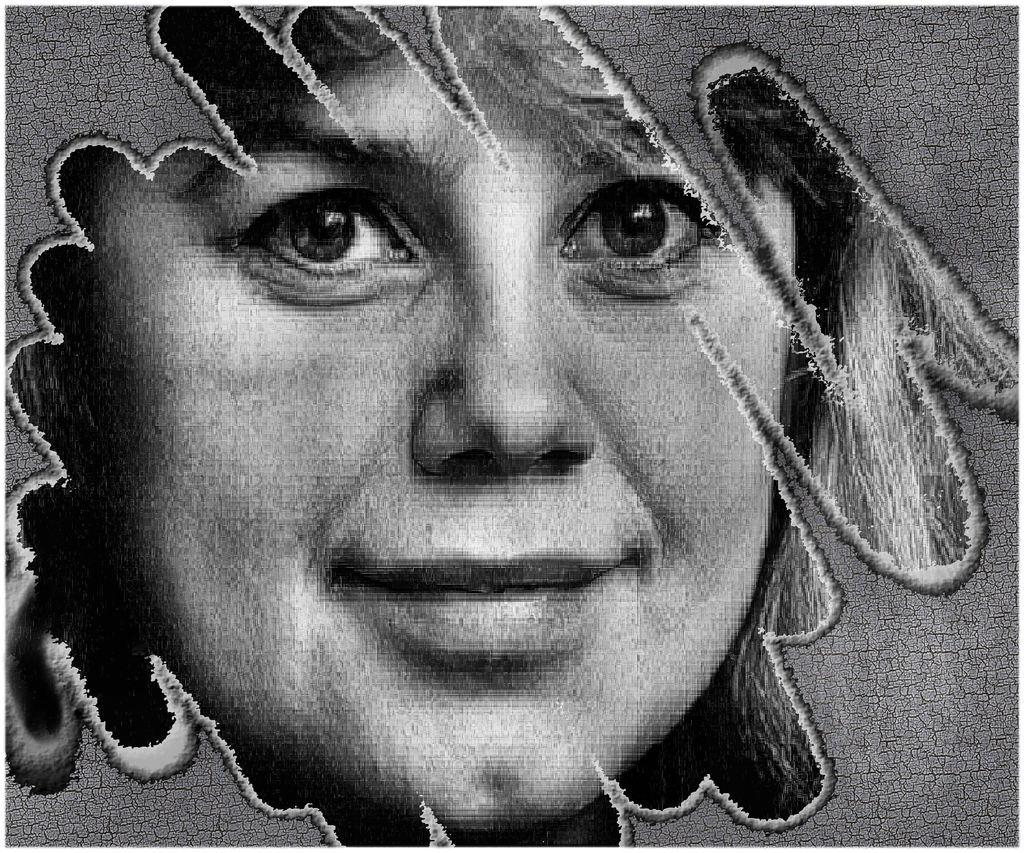What is the main subject of the image? The main subject of the image is an edited picture of a person. What type of mint can be seen growing on the person's chin in the image? There is no mint or any plant growth visible on the person's chin in the image. 